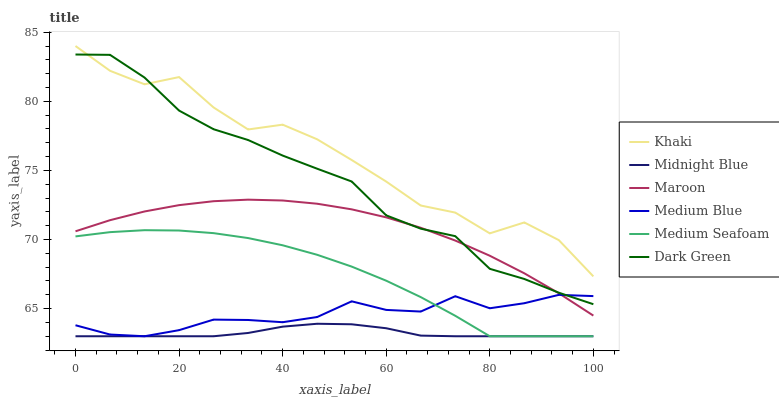Does Midnight Blue have the minimum area under the curve?
Answer yes or no. Yes. Does Khaki have the maximum area under the curve?
Answer yes or no. Yes. Does Medium Blue have the minimum area under the curve?
Answer yes or no. No. Does Medium Blue have the maximum area under the curve?
Answer yes or no. No. Is Midnight Blue the smoothest?
Answer yes or no. Yes. Is Khaki the roughest?
Answer yes or no. Yes. Is Medium Blue the smoothest?
Answer yes or no. No. Is Medium Blue the roughest?
Answer yes or no. No. Does Midnight Blue have the lowest value?
Answer yes or no. Yes. Does Maroon have the lowest value?
Answer yes or no. No. Does Khaki have the highest value?
Answer yes or no. Yes. Does Medium Blue have the highest value?
Answer yes or no. No. Is Midnight Blue less than Dark Green?
Answer yes or no. Yes. Is Khaki greater than Medium Blue?
Answer yes or no. Yes. Does Medium Seafoam intersect Midnight Blue?
Answer yes or no. Yes. Is Medium Seafoam less than Midnight Blue?
Answer yes or no. No. Is Medium Seafoam greater than Midnight Blue?
Answer yes or no. No. Does Midnight Blue intersect Dark Green?
Answer yes or no. No. 